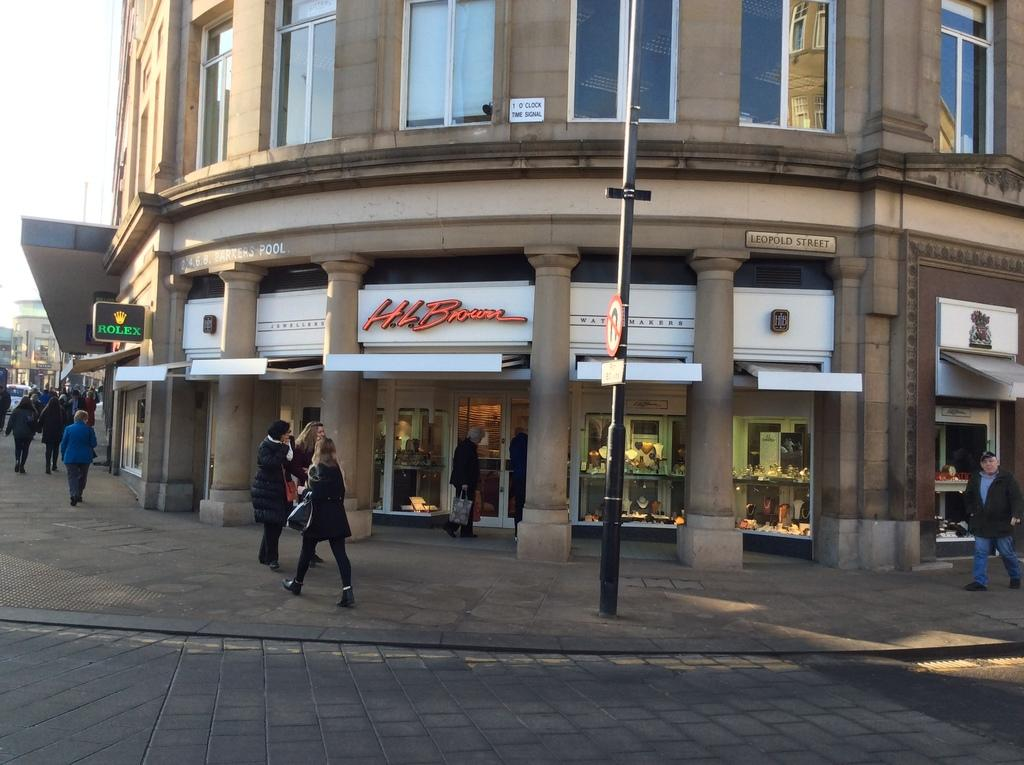What is the main subject of the image? The main subject of the image is a group of people standing. What can be seen in the background of the image? There is a building and shops visible in the background of the image. What type of objects are present in the image? There are boards and other objects present in the image. What type of frame is being used to learn in the image? There is no frame or learning activity depicted in the image. How many pins are visible on the board in the image? There is no board with pins present in the image. 